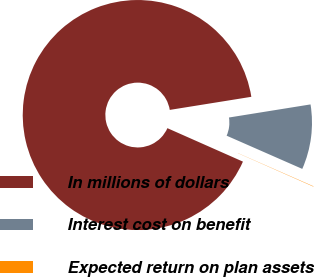<chart> <loc_0><loc_0><loc_500><loc_500><pie_chart><fcel>In millions of dollars<fcel>Interest cost on benefit<fcel>Expected return on plan assets<nl><fcel>90.83%<fcel>9.12%<fcel>0.05%<nl></chart> 